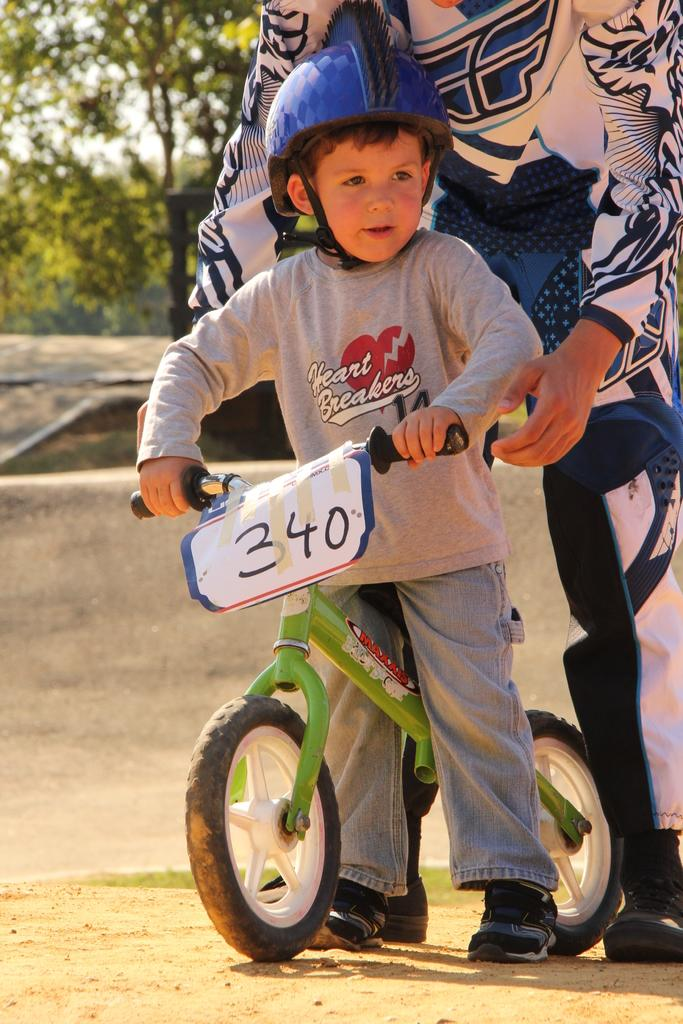What is the main subject of the image? The main subject of the image is a small boy. What is the boy wearing? The boy is wearing a helmet. What is the boy holding? The boy is holding a cycle. What can be seen on the cycle? There is a number plate on the cycle. Who is supporting the boy in the image? A person is holding the boy. What can be seen in the background of the image? There are trees in the background of the image. What type of snails can be seen crawling on the boy's helmet in the image? There are no snails present in the image, and therefore no snails can be seen on the boy's helmet. What kind of coil is used to power the cycle in the image? The image does not show any coil or power source for the cycle. 